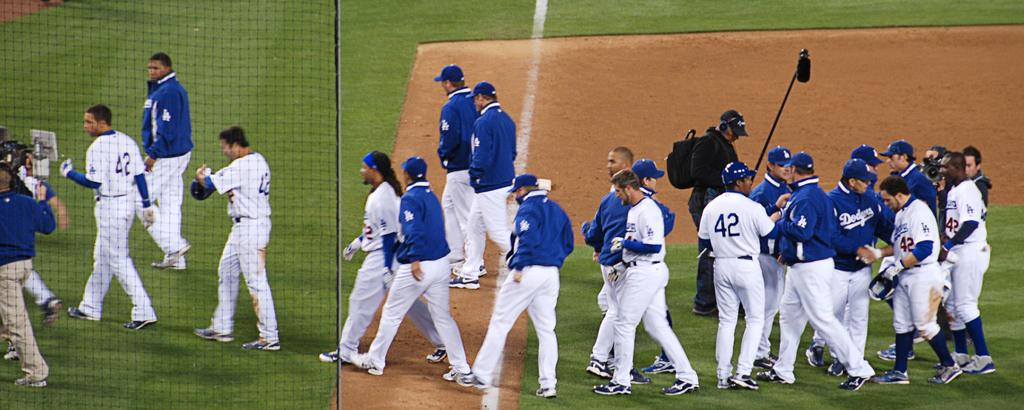<image>
Present a compact description of the photo's key features. Members of a the Dodgers basbeall team mill about as an audio technical holds a microphone above them. 